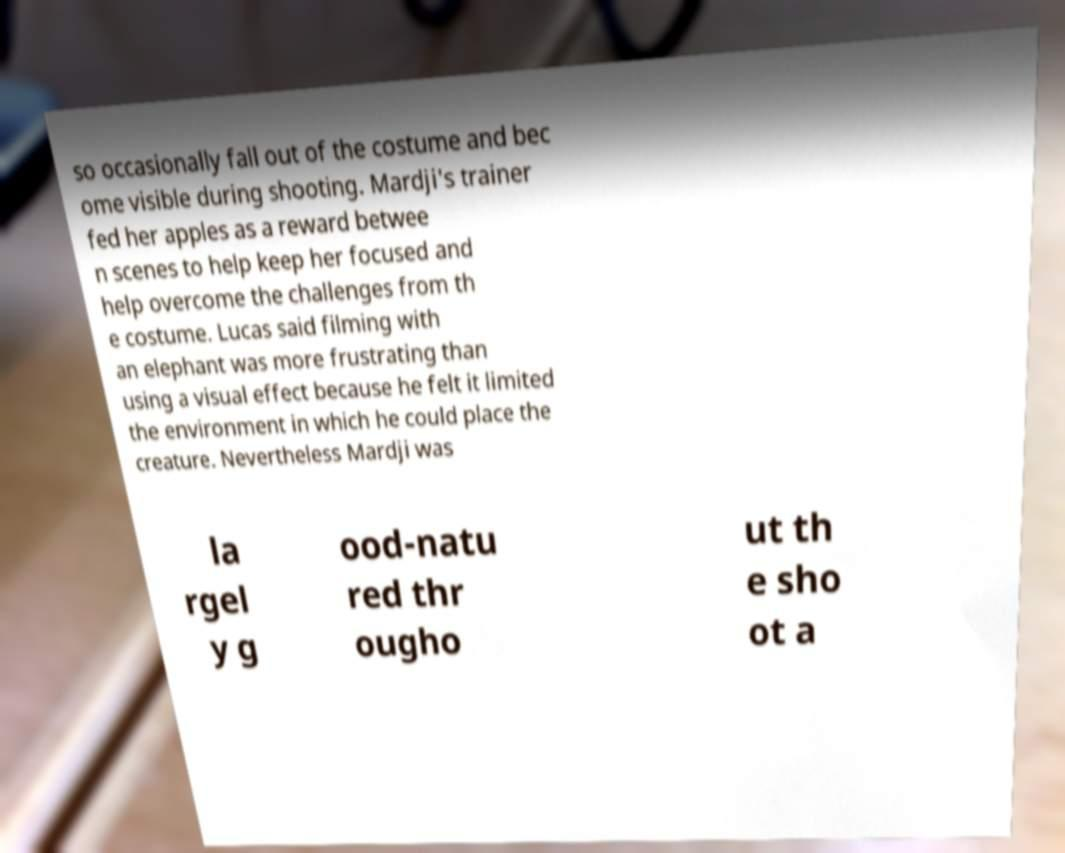For documentation purposes, I need the text within this image transcribed. Could you provide that? so occasionally fall out of the costume and bec ome visible during shooting. Mardji's trainer fed her apples as a reward betwee n scenes to help keep her focused and help overcome the challenges from th e costume. Lucas said filming with an elephant was more frustrating than using a visual effect because he felt it limited the environment in which he could place the creature. Nevertheless Mardji was la rgel y g ood-natu red thr ougho ut th e sho ot a 